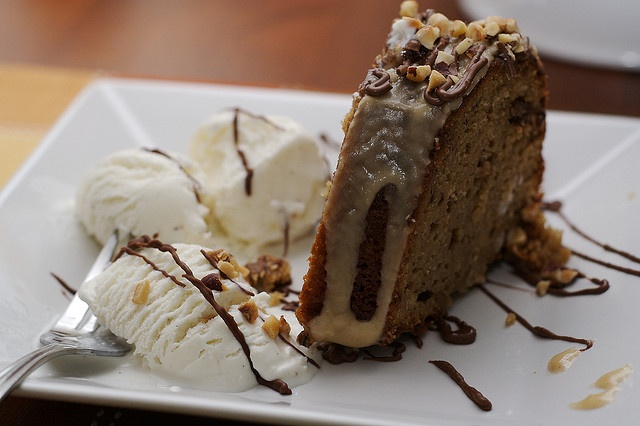Describe the objects in this image and their specific colors. I can see cake in gray, black, and maroon tones, cake in gray, darkgray, tan, lightgray, and black tones, cake in gray, tan, and lightgray tones, and fork in gray, darkgray, lightgray, and black tones in this image. 